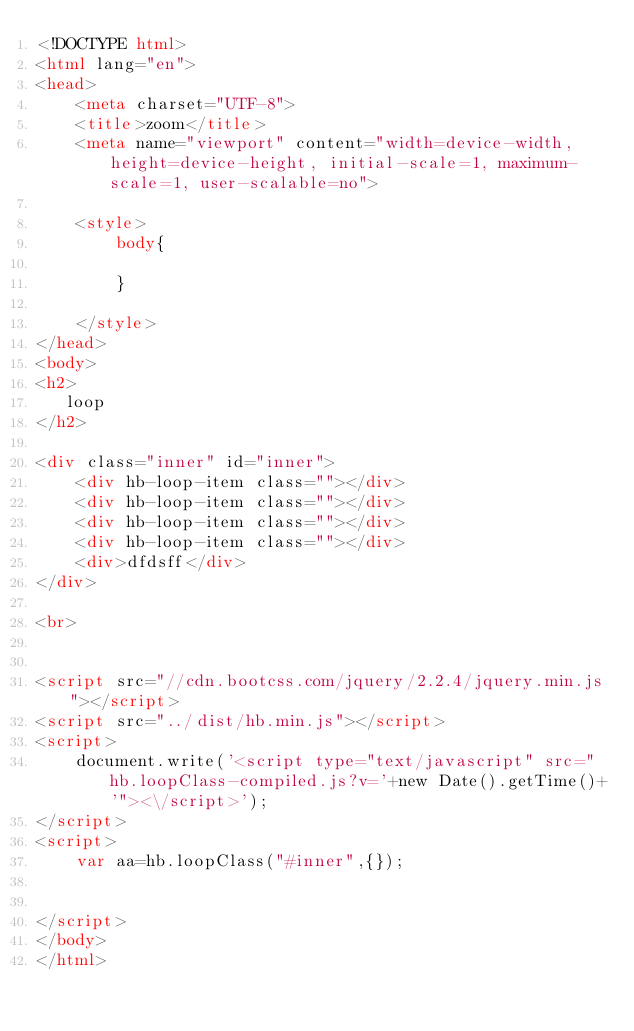<code> <loc_0><loc_0><loc_500><loc_500><_HTML_><!DOCTYPE html>
<html lang="en">
<head>
    <meta charset="UTF-8">
    <title>zoom</title>
    <meta name="viewport" content="width=device-width,height=device-height, initial-scale=1, maximum-scale=1, user-scalable=no">

    <style>
        body{
            
        }

    </style>
</head>
<body>
<h2>
   loop
</h2>

<div class="inner" id="inner">
    <div hb-loop-item class=""></div>
    <div hb-loop-item class=""></div>
    <div hb-loop-item class=""></div>
    <div hb-loop-item class=""></div>
    <div>dfdsff</div>
</div>

<br>


<script src="//cdn.bootcss.com/jquery/2.2.4/jquery.min.js"></script>
<script src="../dist/hb.min.js"></script>
<script>
    document.write('<script type="text/javascript" src="hb.loopClass-compiled.js?v='+new Date().getTime()+'"><\/script>');
</script>
<script>
    var aa=hb.loopClass("#inner",{});


</script>
</body>
</html></code> 